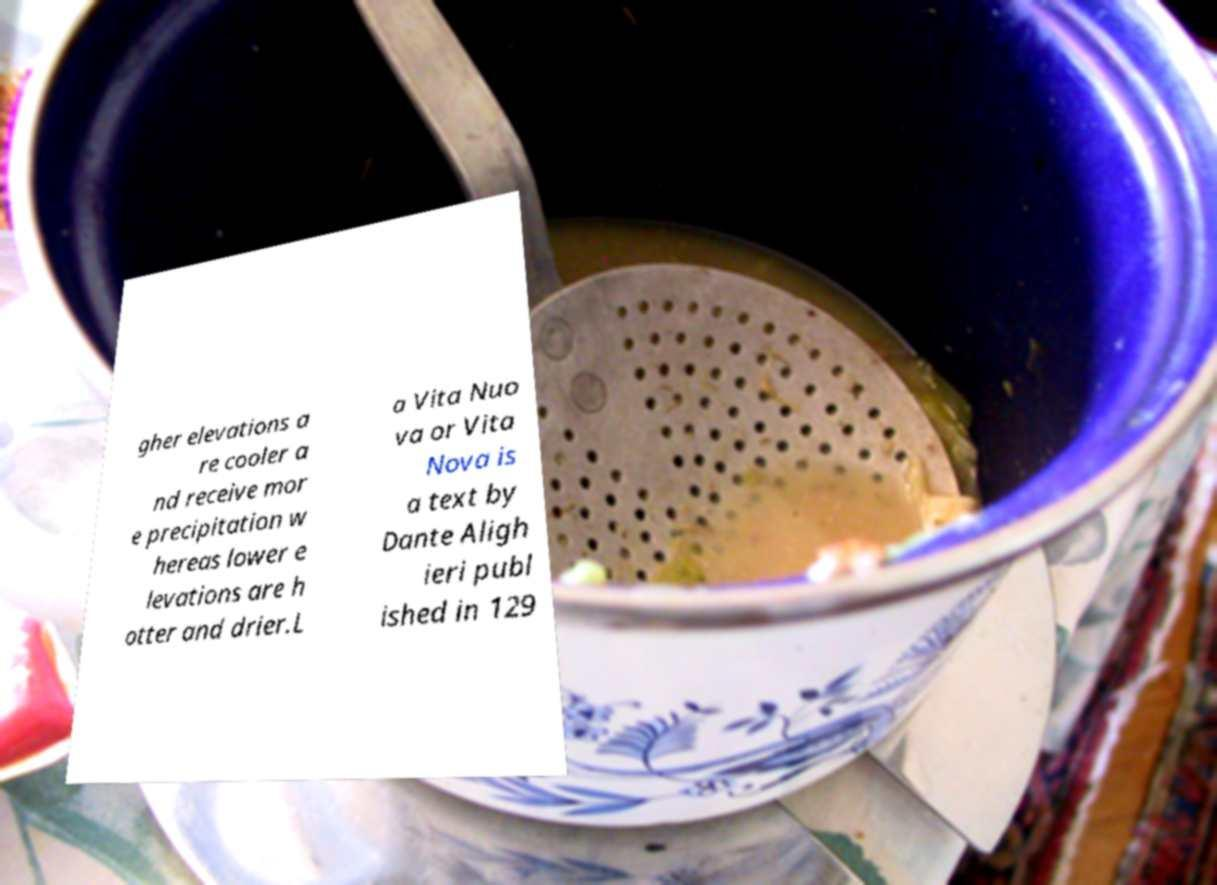Could you assist in decoding the text presented in this image and type it out clearly? gher elevations a re cooler a nd receive mor e precipitation w hereas lower e levations are h otter and drier.L a Vita Nuo va or Vita Nova is a text by Dante Aligh ieri publ ished in 129 